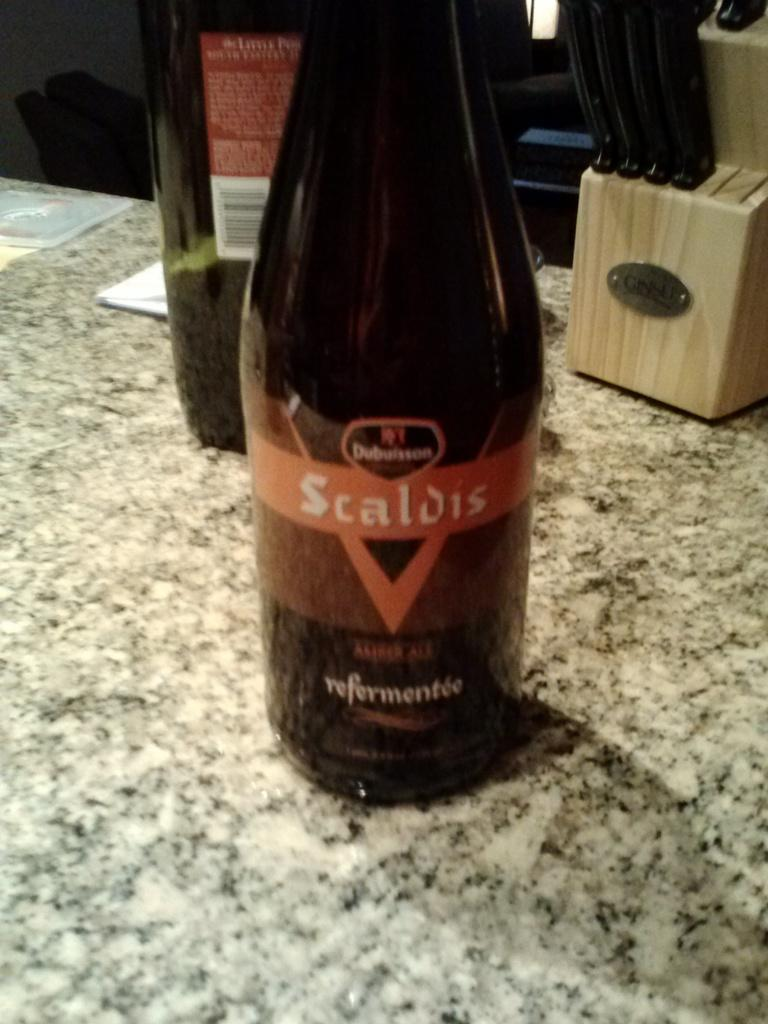<image>
Write a terse but informative summary of the picture. A bottle of Scaldis sits on a stone counter. 